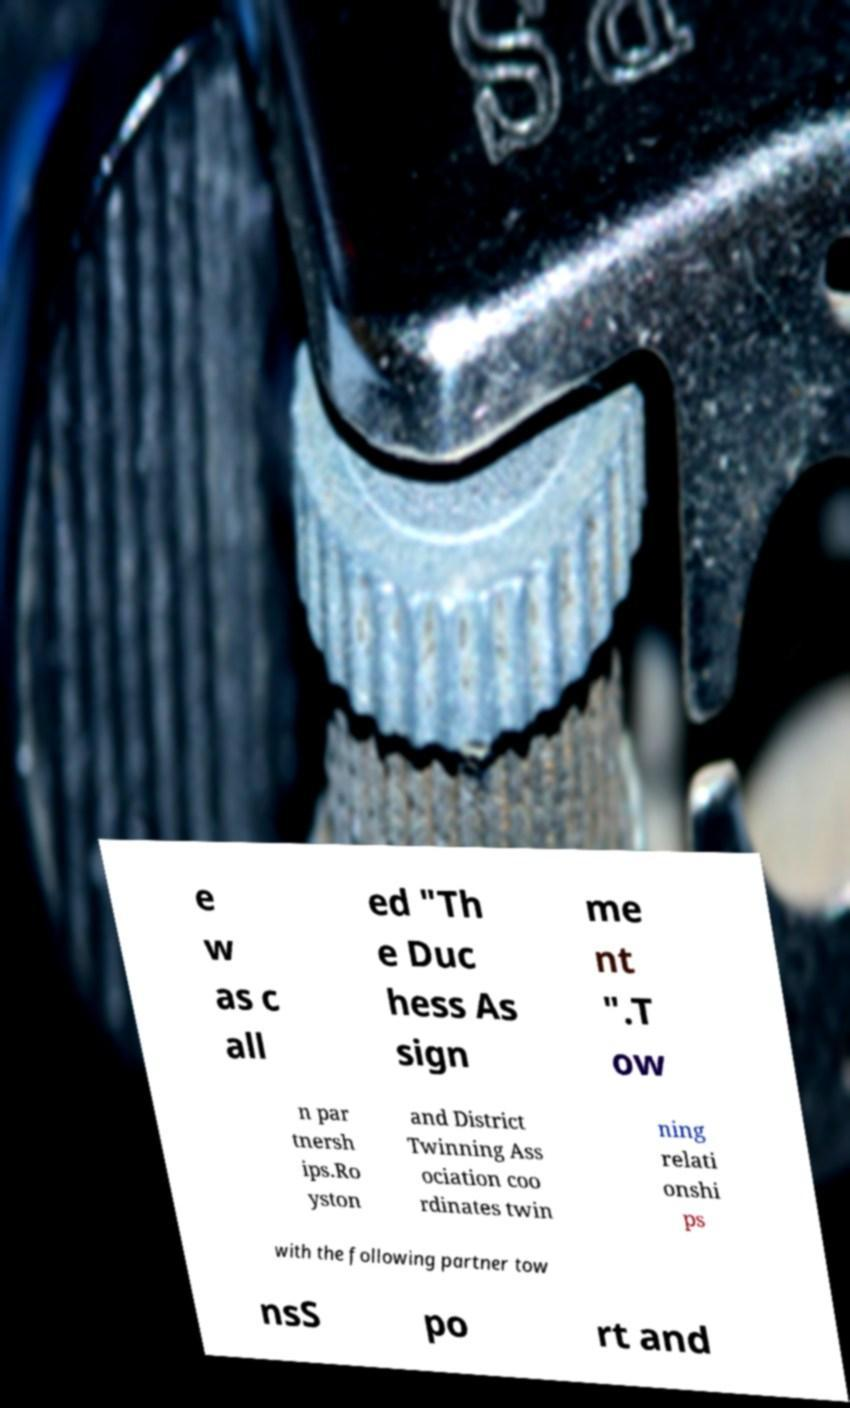Could you assist in decoding the text presented in this image and type it out clearly? e w as c all ed "Th e Duc hess As sign me nt ".T ow n par tnersh ips.Ro yston and District Twinning Ass ociation coo rdinates twin ning relati onshi ps with the following partner tow nsS po rt and 